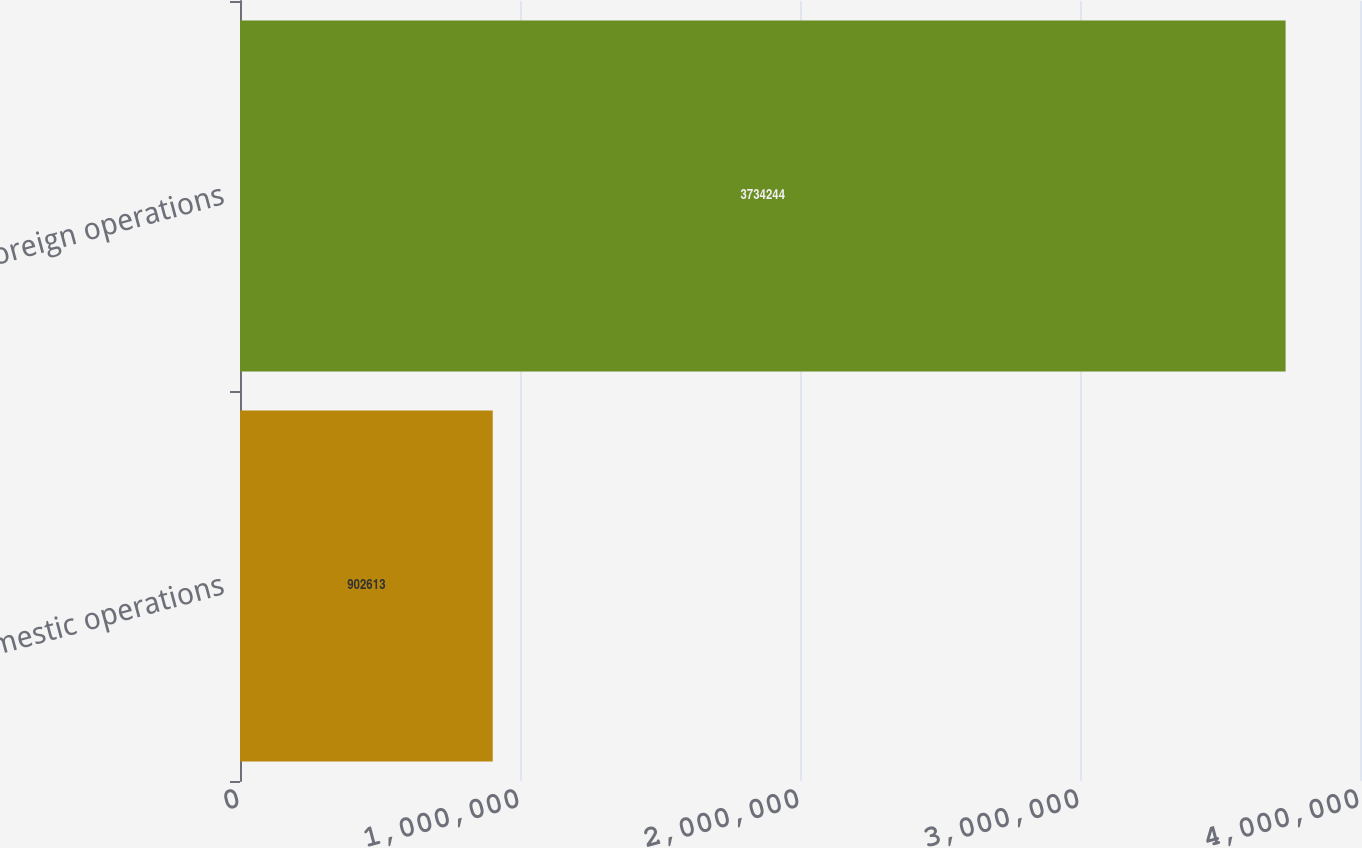Convert chart. <chart><loc_0><loc_0><loc_500><loc_500><bar_chart><fcel>Domestic operations<fcel>Foreign operations<nl><fcel>902613<fcel>3.73424e+06<nl></chart> 